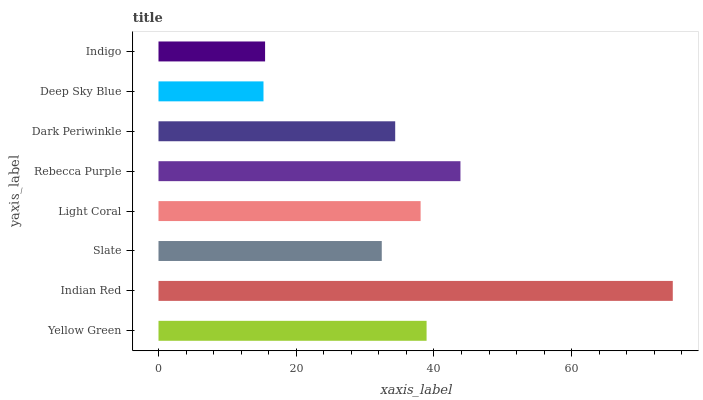Is Deep Sky Blue the minimum?
Answer yes or no. Yes. Is Indian Red the maximum?
Answer yes or no. Yes. Is Slate the minimum?
Answer yes or no. No. Is Slate the maximum?
Answer yes or no. No. Is Indian Red greater than Slate?
Answer yes or no. Yes. Is Slate less than Indian Red?
Answer yes or no. Yes. Is Slate greater than Indian Red?
Answer yes or no. No. Is Indian Red less than Slate?
Answer yes or no. No. Is Light Coral the high median?
Answer yes or no. Yes. Is Dark Periwinkle the low median?
Answer yes or no. Yes. Is Yellow Green the high median?
Answer yes or no. No. Is Rebecca Purple the low median?
Answer yes or no. No. 